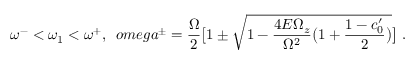<formula> <loc_0><loc_0><loc_500><loc_500>\omega ^ { - } < \omega _ { 1 } < \omega ^ { + } , \ \, o m e g a ^ { \pm } = \frac { \Omega } { 2 } \left [ 1 \pm \sqrt { 1 - \frac { 4 E \Omega _ { z } } { \Omega ^ { 2 } } \left ( 1 + \frac { 1 - c _ { 0 } ^ { \prime } } { 2 } \right ) } \right ] \ .</formula> 